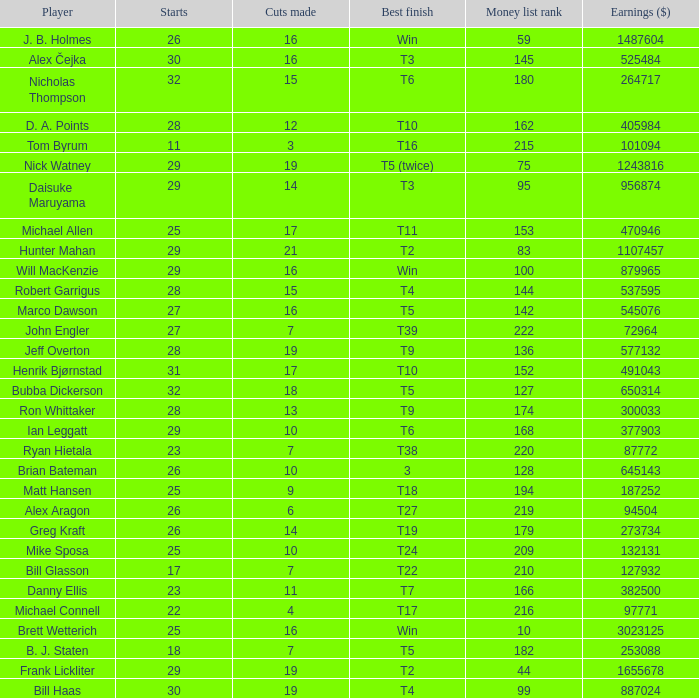What is the lowest monetary ranking for players with a top finish of t9? 136.0. Can you give me this table as a dict? {'header': ['Player', 'Starts', 'Cuts made', 'Best finish', 'Money list rank', 'Earnings ($)'], 'rows': [['J. B. Holmes', '26', '16', 'Win', '59', '1487604'], ['Alex Čejka', '30', '16', 'T3', '145', '525484'], ['Nicholas Thompson', '32', '15', 'T6', '180', '264717'], ['D. A. Points', '28', '12', 'T10', '162', '405984'], ['Tom Byrum', '11', '3', 'T16', '215', '101094'], ['Nick Watney', '29', '19', 'T5 (twice)', '75', '1243816'], ['Daisuke Maruyama', '29', '14', 'T3', '95', '956874'], ['Michael Allen', '25', '17', 'T11', '153', '470946'], ['Hunter Mahan', '29', '21', 'T2', '83', '1107457'], ['Will MacKenzie', '29', '16', 'Win', '100', '879965'], ['Robert Garrigus', '28', '15', 'T4', '144', '537595'], ['Marco Dawson', '27', '16', 'T5', '142', '545076'], ['John Engler', '27', '7', 'T39', '222', '72964'], ['Jeff Overton', '28', '19', 'T9', '136', '577132'], ['Henrik Bjørnstad', '31', '17', 'T10', '152', '491043'], ['Bubba Dickerson', '32', '18', 'T5', '127', '650314'], ['Ron Whittaker', '28', '13', 'T9', '174', '300033'], ['Ian Leggatt', '29', '10', 'T6', '168', '377903'], ['Ryan Hietala', '23', '7', 'T38', '220', '87772'], ['Brian Bateman', '26', '10', '3', '128', '645143'], ['Matt Hansen', '25', '9', 'T18', '194', '187252'], ['Alex Aragon', '26', '6', 'T27', '219', '94504'], ['Greg Kraft', '26', '14', 'T19', '179', '273734'], ['Mike Sposa', '25', '10', 'T24', '209', '132131'], ['Bill Glasson', '17', '7', 'T22', '210', '127932'], ['Danny Ellis', '23', '11', 'T7', '166', '382500'], ['Michael Connell', '22', '4', 'T17', '216', '97771'], ['Brett Wetterich', '25', '16', 'Win', '10', '3023125'], ['B. J. Staten', '18', '7', 'T5', '182', '253088'], ['Frank Lickliter', '29', '19', 'T2', '44', '1655678'], ['Bill Haas', '30', '19', 'T4', '99', '887024']]} 